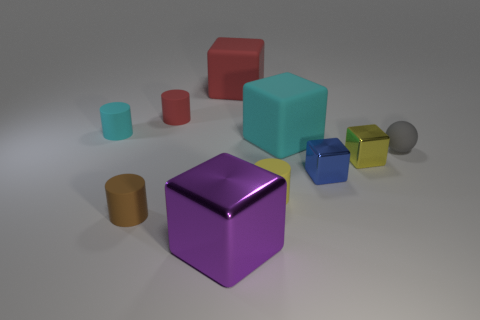Do the big purple thing and the tiny shiny thing in front of the small yellow block have the same shape?
Make the answer very short. Yes. There is a large block to the right of the rubber cube that is behind the small red thing; how many matte objects are to the left of it?
Provide a succinct answer. 5. The shiny object that is the same size as the cyan cube is what color?
Give a very brief answer. Purple. There is a yellow object on the left side of the tiny metal object in front of the small yellow shiny object; what size is it?
Your answer should be very brief. Small. How many other objects are there of the same size as the cyan cube?
Make the answer very short. 2. How many tiny brown cylinders are there?
Your response must be concise. 1. Do the purple object and the cyan matte block have the same size?
Make the answer very short. Yes. What number of other things are there of the same shape as the small cyan thing?
Your answer should be compact. 3. What material is the cyan object on the right side of the tiny cylinder right of the purple block made of?
Your answer should be very brief. Rubber. There is a gray ball; are there any small yellow cubes on the left side of it?
Offer a terse response. Yes. 